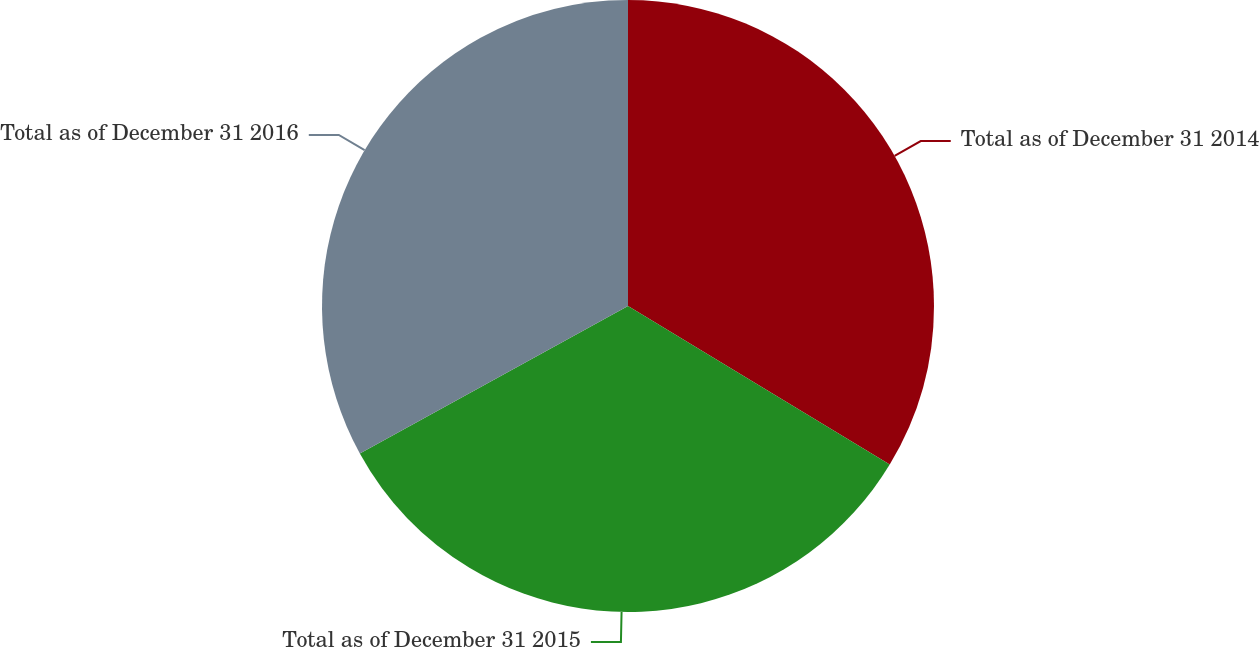Convert chart to OTSL. <chart><loc_0><loc_0><loc_500><loc_500><pie_chart><fcel>Total as of December 31 2014<fcel>Total as of December 31 2015<fcel>Total as of December 31 2016<nl><fcel>33.67%<fcel>33.33%<fcel>33.0%<nl></chart> 